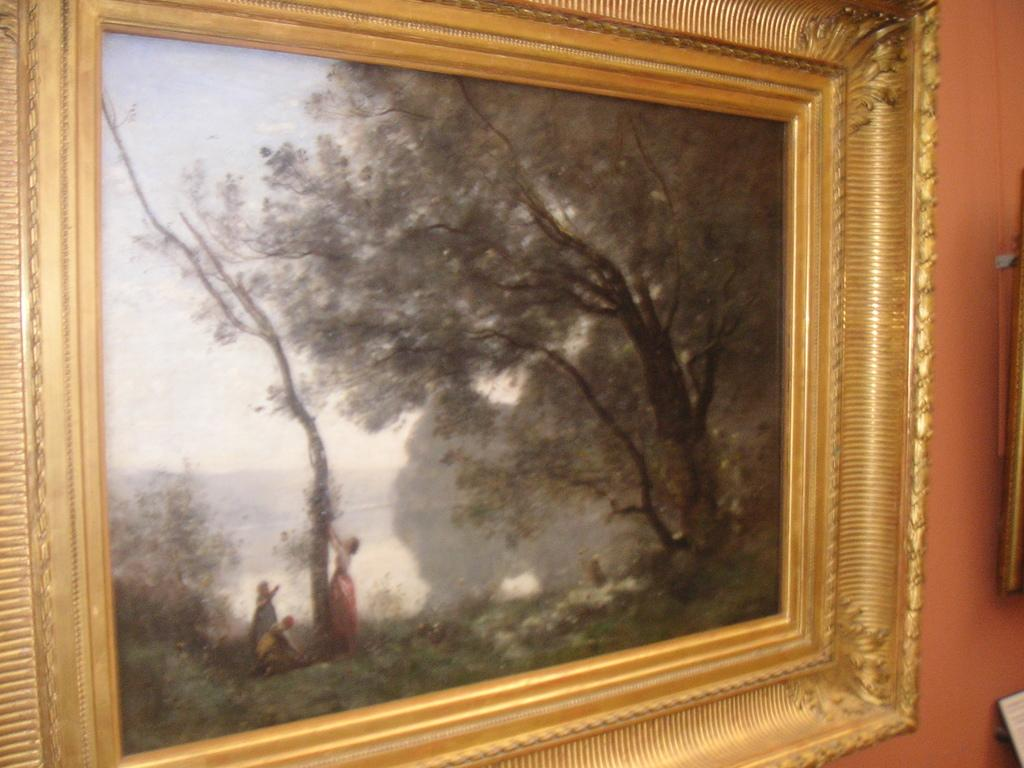What object is present in the image that typically holds a picture? There is a photo frame in the image. What can be seen behind the photo frame? There is a wall in the background of the image. What is visible within the photo frame? There is a tree visible in the photo frame. How far away is the basketball court from the tree in the photo frame? There is no basketball court visible in the image, and the distance cannot be determined from the provided facts. 